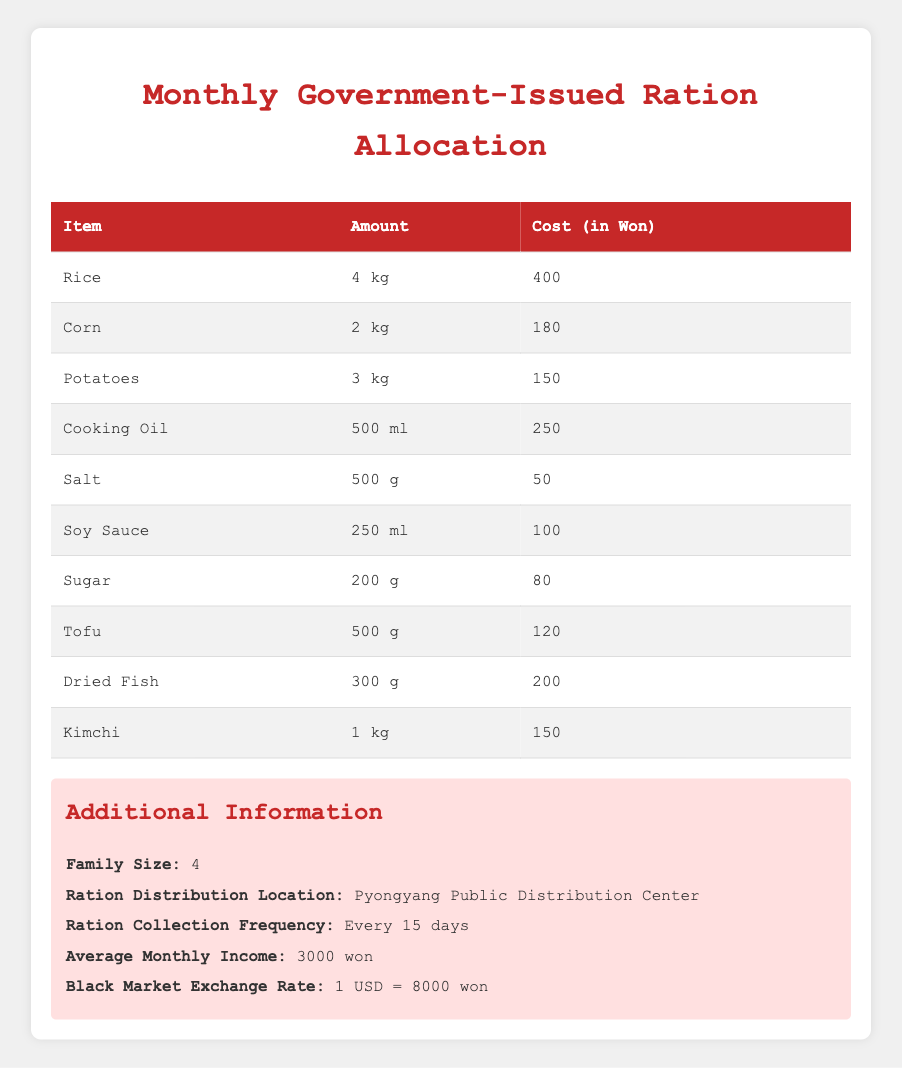What is the total cost of all monthly rations for an average family? To find the total cost, we need to sum the costs of all the individual items listed in the table. This includes 400 (Rice) + 180 (Corn) + 150 (Potatoes) + 250 (Cooking Oil) + 50 (Salt) + 100 (Soy Sauce) + 80 (Sugar) + 120 (Tofu) + 200 (Dried Fish) + 150 (Kimchi) = 1680 won.
Answer: 1680 won How much rice is allocated to a family per month? The table shows that each family receives 4 kg of rice.
Answer: 4 kg Is sugar cheaper than salt based on the monthly ration costs? The cost of sugar is 80 won while salt costs 50 won. Since 80 is greater than 50, sugar is more expensive than salt.
Answer: No What is the total amount of food (in kg) allocated to an average family? To calculate the total food weight, we should consider rice (4 kg) + corn (2 kg) + potatoes (3 kg) + cooking oil (0.5 kg) + salt (0.5 kg) + soy sauce (0.25 kg) + sugar (0.2 kg) + tofu (0.5 kg) + dried fish (0.3 kg) + kimchi (1 kg). The total is 4 + 2 + 3 + 0.5 + 0.5 + 0.25 + 0.2 + 0.5 + 0.3 + 1 = 12.5 kg.
Answer: 12.5 kg Is the allocated monthly income greater than the total cost of rations? The average monthly income is stated as 3000 won, and the total cost of rations we previously calculated is 1680 won. Since 3000 is greater than 1680, the income exceeds the cost of rations.
Answer: Yes How much more does cooking oil cost compared to sugar? Cooking oil costs 250 won and sugar costs 80 won. To find the difference, we subtract the cost of sugar from the cost of cooking oil: 250 - 80 = 170 won.
Answer: 170 won How many items allocated have a cost less than 100 won? By reviewing the costs, salt (50), sugar (80), and soy sauce (100) are the relevant items. Since only salt and sugar have costs below 100 won, there are 2 items.
Answer: 2 items What percentage of the total monthly income is the cost of rice? The cost of rice is 400 won, and the average monthly income is 3000 won. To find the percentage, we calculate (400 / 3000) * 100 = 13.33%.
Answer: 13.33% 